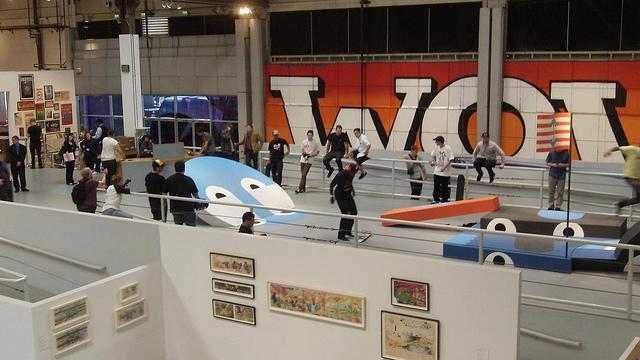How many pictures are there on the wall?
Give a very brief answer. 10. 